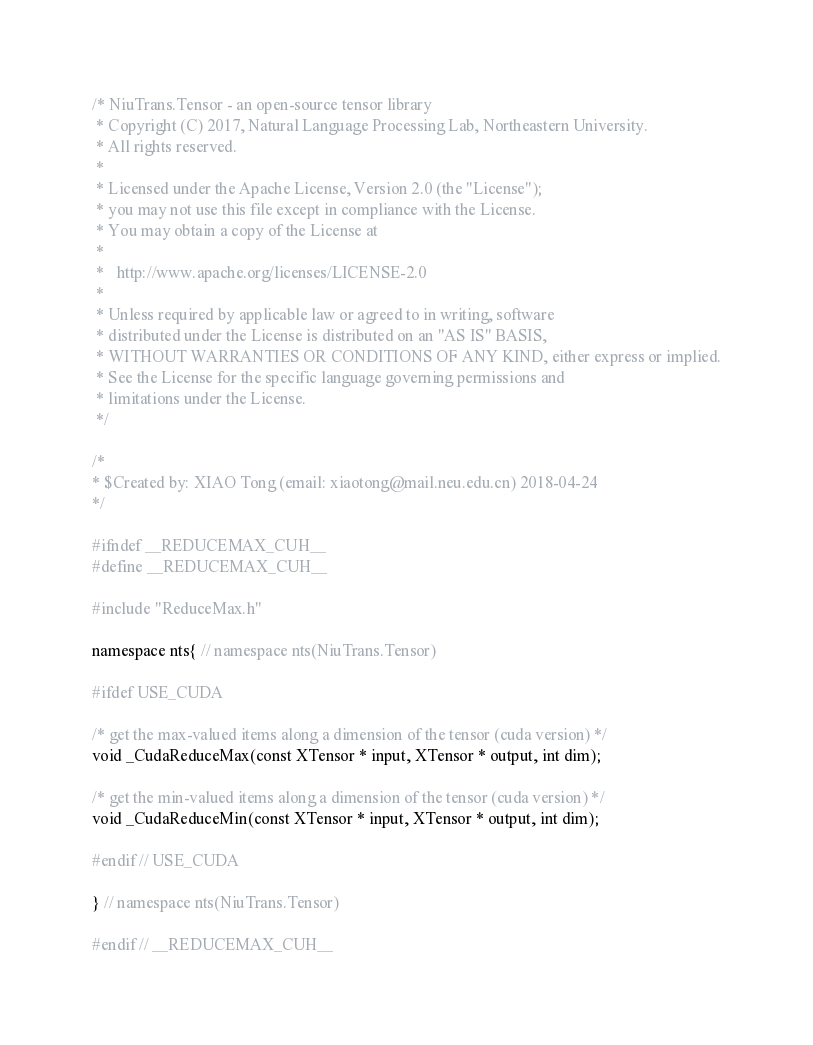Convert code to text. <code><loc_0><loc_0><loc_500><loc_500><_Cuda_>/* NiuTrans.Tensor - an open-source tensor library
 * Copyright (C) 2017, Natural Language Processing Lab, Northeastern University. 
 * All rights reserved.
 *
 * Licensed under the Apache License, Version 2.0 (the "License");
 * you may not use this file except in compliance with the License.
 * You may obtain a copy of the License at
 *
 *   http://www.apache.org/licenses/LICENSE-2.0
 *
 * Unless required by applicable law or agreed to in writing, software
 * distributed under the License is distributed on an "AS IS" BASIS,
 * WITHOUT WARRANTIES OR CONDITIONS OF ANY KIND, either express or implied.
 * See the License for the specific language governing permissions and
 * limitations under the License.
 */

/*
* $Created by: XIAO Tong (email: xiaotong@mail.neu.edu.cn) 2018-04-24
*/

#ifndef __REDUCEMAX_CUH__
#define __REDUCEMAX_CUH__

#include "ReduceMax.h"

namespace nts{ // namespace nts(NiuTrans.Tensor)

#ifdef USE_CUDA

/* get the max-valued items along a dimension of the tensor (cuda version) */
void _CudaReduceMax(const XTensor * input, XTensor * output, int dim);

/* get the min-valued items along a dimension of the tensor (cuda version) */
void _CudaReduceMin(const XTensor * input, XTensor * output, int dim);

#endif // USE_CUDA

} // namespace nts(NiuTrans.Tensor)

#endif // __REDUCEMAX_CUH__

</code> 